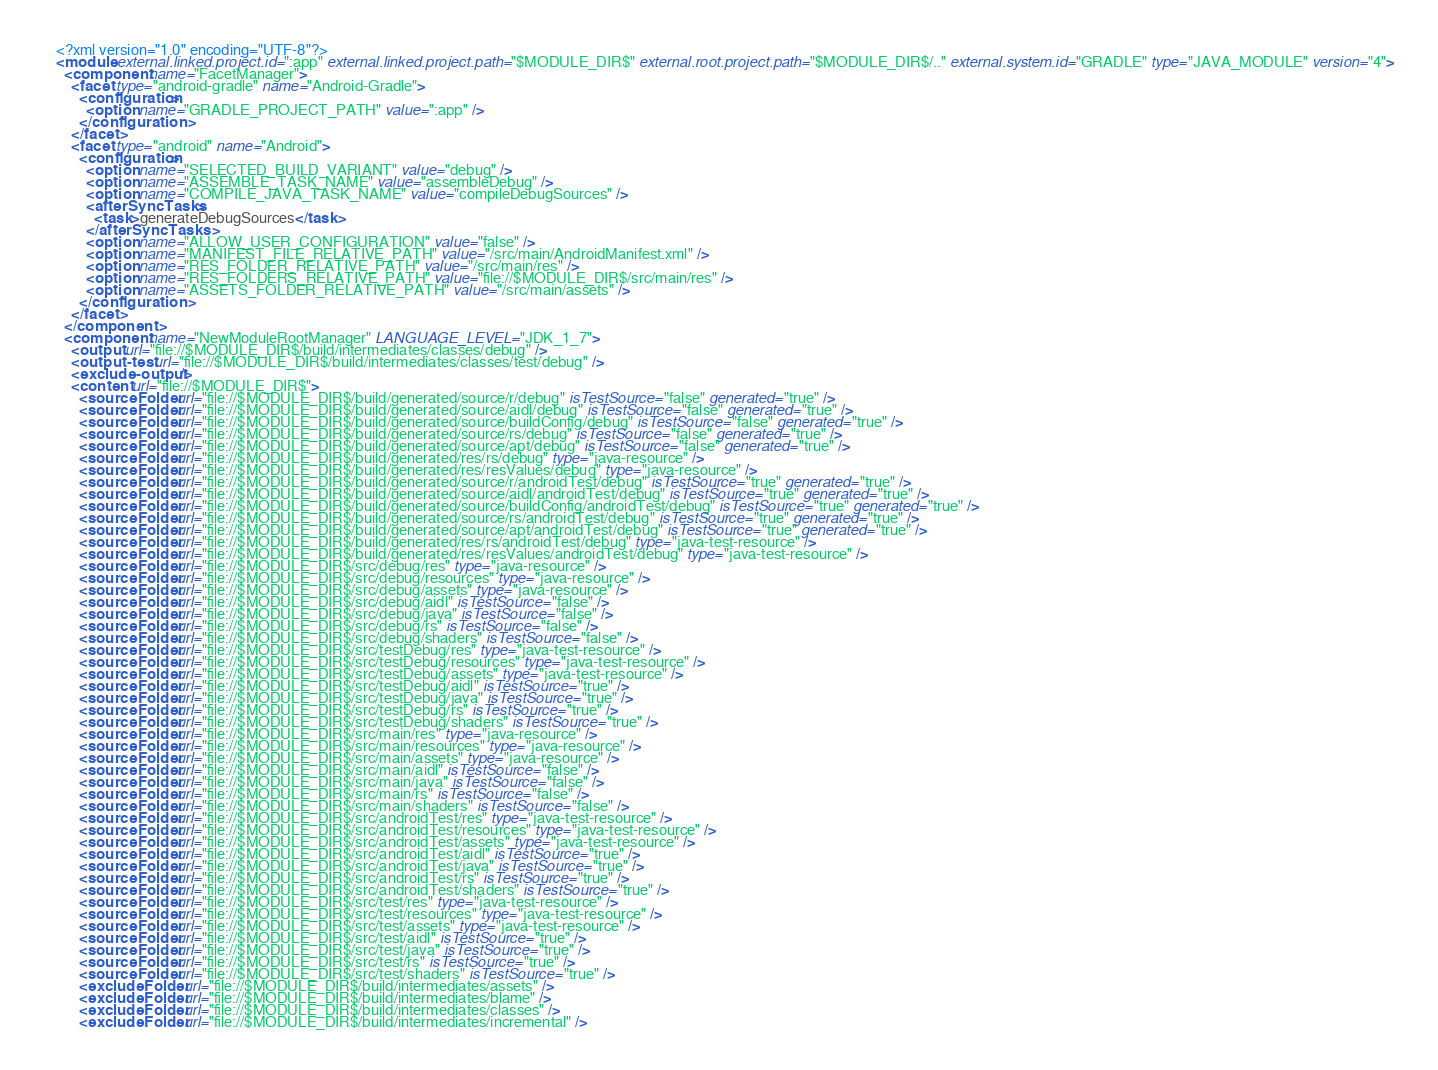Convert code to text. <code><loc_0><loc_0><loc_500><loc_500><_XML_><?xml version="1.0" encoding="UTF-8"?>
<module external.linked.project.id=":app" external.linked.project.path="$MODULE_DIR$" external.root.project.path="$MODULE_DIR$/.." external.system.id="GRADLE" type="JAVA_MODULE" version="4">
  <component name="FacetManager">
    <facet type="android-gradle" name="Android-Gradle">
      <configuration>
        <option name="GRADLE_PROJECT_PATH" value=":app" />
      </configuration>
    </facet>
    <facet type="android" name="Android">
      <configuration>
        <option name="SELECTED_BUILD_VARIANT" value="debug" />
        <option name="ASSEMBLE_TASK_NAME" value="assembleDebug" />
        <option name="COMPILE_JAVA_TASK_NAME" value="compileDebugSources" />
        <afterSyncTasks>
          <task>generateDebugSources</task>
        </afterSyncTasks>
        <option name="ALLOW_USER_CONFIGURATION" value="false" />
        <option name="MANIFEST_FILE_RELATIVE_PATH" value="/src/main/AndroidManifest.xml" />
        <option name="RES_FOLDER_RELATIVE_PATH" value="/src/main/res" />
        <option name="RES_FOLDERS_RELATIVE_PATH" value="file://$MODULE_DIR$/src/main/res" />
        <option name="ASSETS_FOLDER_RELATIVE_PATH" value="/src/main/assets" />
      </configuration>
    </facet>
  </component>
  <component name="NewModuleRootManager" LANGUAGE_LEVEL="JDK_1_7">
    <output url="file://$MODULE_DIR$/build/intermediates/classes/debug" />
    <output-test url="file://$MODULE_DIR$/build/intermediates/classes/test/debug" />
    <exclude-output />
    <content url="file://$MODULE_DIR$">
      <sourceFolder url="file://$MODULE_DIR$/build/generated/source/r/debug" isTestSource="false" generated="true" />
      <sourceFolder url="file://$MODULE_DIR$/build/generated/source/aidl/debug" isTestSource="false" generated="true" />
      <sourceFolder url="file://$MODULE_DIR$/build/generated/source/buildConfig/debug" isTestSource="false" generated="true" />
      <sourceFolder url="file://$MODULE_DIR$/build/generated/source/rs/debug" isTestSource="false" generated="true" />
      <sourceFolder url="file://$MODULE_DIR$/build/generated/source/apt/debug" isTestSource="false" generated="true" />
      <sourceFolder url="file://$MODULE_DIR$/build/generated/res/rs/debug" type="java-resource" />
      <sourceFolder url="file://$MODULE_DIR$/build/generated/res/resValues/debug" type="java-resource" />
      <sourceFolder url="file://$MODULE_DIR$/build/generated/source/r/androidTest/debug" isTestSource="true" generated="true" />
      <sourceFolder url="file://$MODULE_DIR$/build/generated/source/aidl/androidTest/debug" isTestSource="true" generated="true" />
      <sourceFolder url="file://$MODULE_DIR$/build/generated/source/buildConfig/androidTest/debug" isTestSource="true" generated="true" />
      <sourceFolder url="file://$MODULE_DIR$/build/generated/source/rs/androidTest/debug" isTestSource="true" generated="true" />
      <sourceFolder url="file://$MODULE_DIR$/build/generated/source/apt/androidTest/debug" isTestSource="true" generated="true" />
      <sourceFolder url="file://$MODULE_DIR$/build/generated/res/rs/androidTest/debug" type="java-test-resource" />
      <sourceFolder url="file://$MODULE_DIR$/build/generated/res/resValues/androidTest/debug" type="java-test-resource" />
      <sourceFolder url="file://$MODULE_DIR$/src/debug/res" type="java-resource" />
      <sourceFolder url="file://$MODULE_DIR$/src/debug/resources" type="java-resource" />
      <sourceFolder url="file://$MODULE_DIR$/src/debug/assets" type="java-resource" />
      <sourceFolder url="file://$MODULE_DIR$/src/debug/aidl" isTestSource="false" />
      <sourceFolder url="file://$MODULE_DIR$/src/debug/java" isTestSource="false" />
      <sourceFolder url="file://$MODULE_DIR$/src/debug/rs" isTestSource="false" />
      <sourceFolder url="file://$MODULE_DIR$/src/debug/shaders" isTestSource="false" />
      <sourceFolder url="file://$MODULE_DIR$/src/testDebug/res" type="java-test-resource" />
      <sourceFolder url="file://$MODULE_DIR$/src/testDebug/resources" type="java-test-resource" />
      <sourceFolder url="file://$MODULE_DIR$/src/testDebug/assets" type="java-test-resource" />
      <sourceFolder url="file://$MODULE_DIR$/src/testDebug/aidl" isTestSource="true" />
      <sourceFolder url="file://$MODULE_DIR$/src/testDebug/java" isTestSource="true" />
      <sourceFolder url="file://$MODULE_DIR$/src/testDebug/rs" isTestSource="true" />
      <sourceFolder url="file://$MODULE_DIR$/src/testDebug/shaders" isTestSource="true" />
      <sourceFolder url="file://$MODULE_DIR$/src/main/res" type="java-resource" />
      <sourceFolder url="file://$MODULE_DIR$/src/main/resources" type="java-resource" />
      <sourceFolder url="file://$MODULE_DIR$/src/main/assets" type="java-resource" />
      <sourceFolder url="file://$MODULE_DIR$/src/main/aidl" isTestSource="false" />
      <sourceFolder url="file://$MODULE_DIR$/src/main/java" isTestSource="false" />
      <sourceFolder url="file://$MODULE_DIR$/src/main/rs" isTestSource="false" />
      <sourceFolder url="file://$MODULE_DIR$/src/main/shaders" isTestSource="false" />
      <sourceFolder url="file://$MODULE_DIR$/src/androidTest/res" type="java-test-resource" />
      <sourceFolder url="file://$MODULE_DIR$/src/androidTest/resources" type="java-test-resource" />
      <sourceFolder url="file://$MODULE_DIR$/src/androidTest/assets" type="java-test-resource" />
      <sourceFolder url="file://$MODULE_DIR$/src/androidTest/aidl" isTestSource="true" />
      <sourceFolder url="file://$MODULE_DIR$/src/androidTest/java" isTestSource="true" />
      <sourceFolder url="file://$MODULE_DIR$/src/androidTest/rs" isTestSource="true" />
      <sourceFolder url="file://$MODULE_DIR$/src/androidTest/shaders" isTestSource="true" />
      <sourceFolder url="file://$MODULE_DIR$/src/test/res" type="java-test-resource" />
      <sourceFolder url="file://$MODULE_DIR$/src/test/resources" type="java-test-resource" />
      <sourceFolder url="file://$MODULE_DIR$/src/test/assets" type="java-test-resource" />
      <sourceFolder url="file://$MODULE_DIR$/src/test/aidl" isTestSource="true" />
      <sourceFolder url="file://$MODULE_DIR$/src/test/java" isTestSource="true" />
      <sourceFolder url="file://$MODULE_DIR$/src/test/rs" isTestSource="true" />
      <sourceFolder url="file://$MODULE_DIR$/src/test/shaders" isTestSource="true" />
      <excludeFolder url="file://$MODULE_DIR$/build/intermediates/assets" />
      <excludeFolder url="file://$MODULE_DIR$/build/intermediates/blame" />
      <excludeFolder url="file://$MODULE_DIR$/build/intermediates/classes" />
      <excludeFolder url="file://$MODULE_DIR$/build/intermediates/incremental" /></code> 